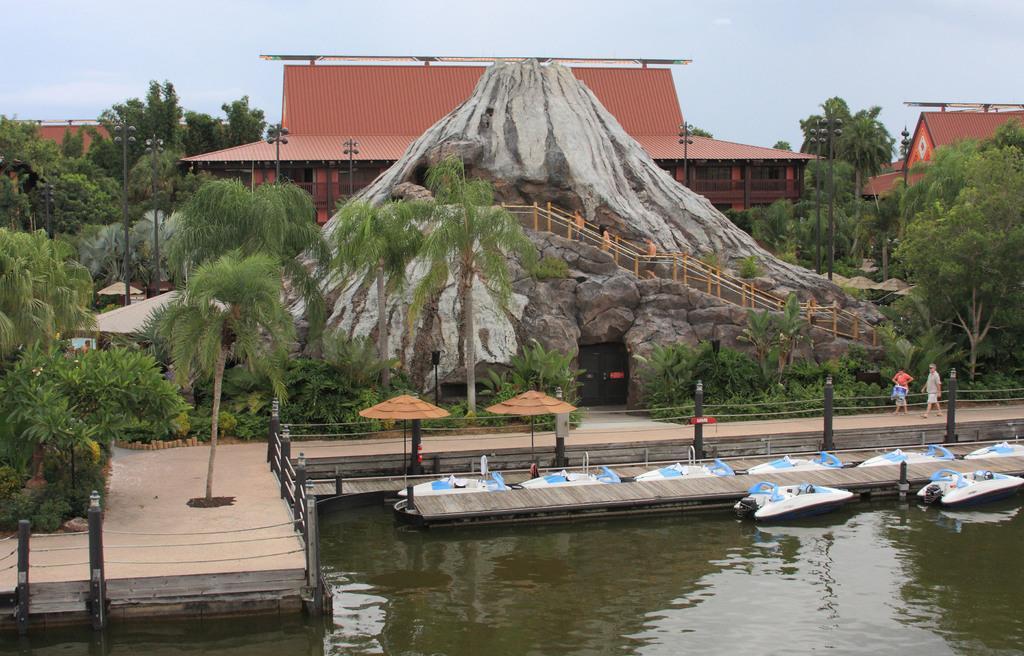How would you summarize this image in a sentence or two? In this picture there are few boats on the water and there are two persons standing in the right corner and there is a mountain,trees,poles and buildings in the background. 